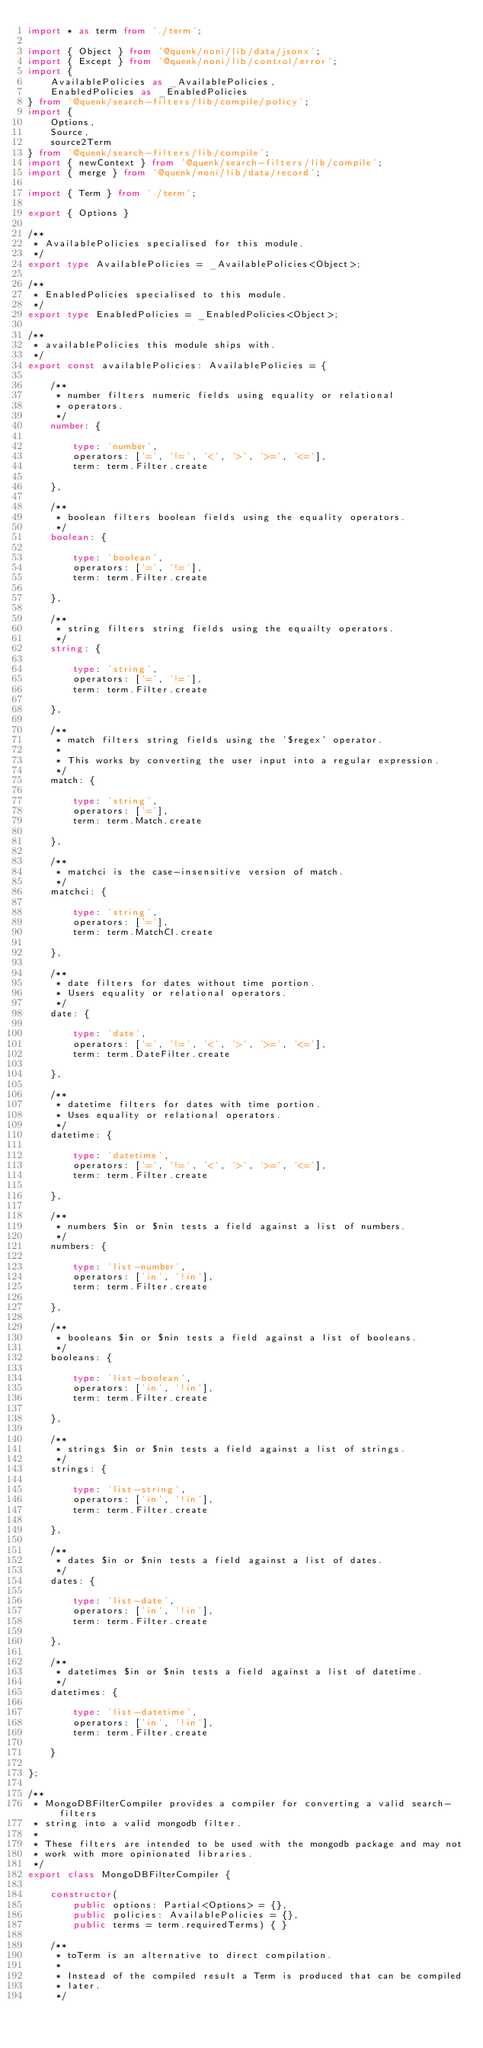Convert code to text. <code><loc_0><loc_0><loc_500><loc_500><_TypeScript_>import * as term from './term';

import { Object } from '@quenk/noni/lib/data/jsonx';
import { Except } from '@quenk/noni/lib/control/error';
import {
    AvailablePolicies as _AvailablePolicies,
    EnabledPolicies as _EnabledPolicies
} from '@quenk/search-filters/lib/compile/policy';
import {
    Options,
    Source,
    source2Term
} from '@quenk/search-filters/lib/compile';
import { newContext } from '@quenk/search-filters/lib/compile';
import { merge } from '@quenk/noni/lib/data/record';

import { Term } from './term';

export { Options }

/**
 * AvailablePolicies specialised for this module.
 */
export type AvailablePolicies = _AvailablePolicies<Object>;

/**
 * EnabledPolicies specialised to this module.
 */
export type EnabledPolicies = _EnabledPolicies<Object>;

/**
 * availablePolicies this module ships with.
 */
export const availablePolicies: AvailablePolicies = {

    /**
     * number filters numeric fields using equality or relational
     * operators.
     */
    number: {

        type: 'number',
        operators: ['=', '!=', '<', '>', '>=', '<='],
        term: term.Filter.create

    },

    /**
     * boolean filters boolean fields using the equality operators.
     */
    boolean: {

        type: 'boolean',
        operators: ['=', '!='],
        term: term.Filter.create

    },

    /**
     * string filters string fields using the equailty operators.
     */
    string: {

        type: 'string',
        operators: ['=', '!='],
        term: term.Filter.create

    },

    /**
     * match filters string fields using the '$regex' operator.
     *
     * This works by converting the user input into a regular expression.
     */
    match: {

        type: 'string',
        operators: ['='],
        term: term.Match.create

    },

    /**
     * matchci is the case-insensitive version of match.
     */
    matchci: {

        type: 'string',
        operators: ['='],
        term: term.MatchCI.create

    },

    /**
     * date filters for dates without time portion.
     * Users equality or relational operators.
     */
    date: {

        type: 'date',
        operators: ['=', '!=', '<', '>', '>=', '<='],
        term: term.DateFilter.create

    },

    /**
     * datetime filters for dates with time portion.
     * Uses equality or relational operators.
     */
    datetime: {

        type: 'datetime',
        operators: ['=', '!=', '<', '>', '>=', '<='],
        term: term.Filter.create

    },

    /**
     * numbers $in or $nin tests a field against a list of numbers.
     */
    numbers: {

        type: 'list-number',
        operators: ['in', '!in'],
        term: term.Filter.create

    },

    /**
     * booleans $in or $nin tests a field against a list of booleans.
     */
    booleans: {

        type: 'list-boolean',
        operators: ['in', '!in'],
        term: term.Filter.create

    },

    /**
     * strings $in or $nin tests a field against a list of strings.
     */
    strings: {

        type: 'list-string',
        operators: ['in', '!in'],
        term: term.Filter.create

    },

    /**
     * dates $in or $nin tests a field against a list of dates.
     */
    dates: {

        type: 'list-date',
        operators: ['in', '!in'],
        term: term.Filter.create

    },

    /**
     * datetimes $in or $nin tests a field against a list of datetime.
     */
    datetimes: {

        type: 'list-datetime',
        operators: ['in', '!in'],
        term: term.Filter.create

    }

};

/**
 * MongoDBFilterCompiler provides a compiler for converting a valid search-filters
 * string into a valid mongodb filter. 
 *
 * These filters are intended to be used with the mongodb package and may not
 * work with more opinionated libraries.
 */
export class MongoDBFilterCompiler {

    constructor(
        public options: Partial<Options> = {},
        public policies: AvailablePolicies = {},
        public terms = term.requiredTerms) { }

    /**
     * toTerm is an alternative to direct compilation.
     *
     * Instead of the compiled result a Term is produced that can be compiled
     * later.
     */</code> 